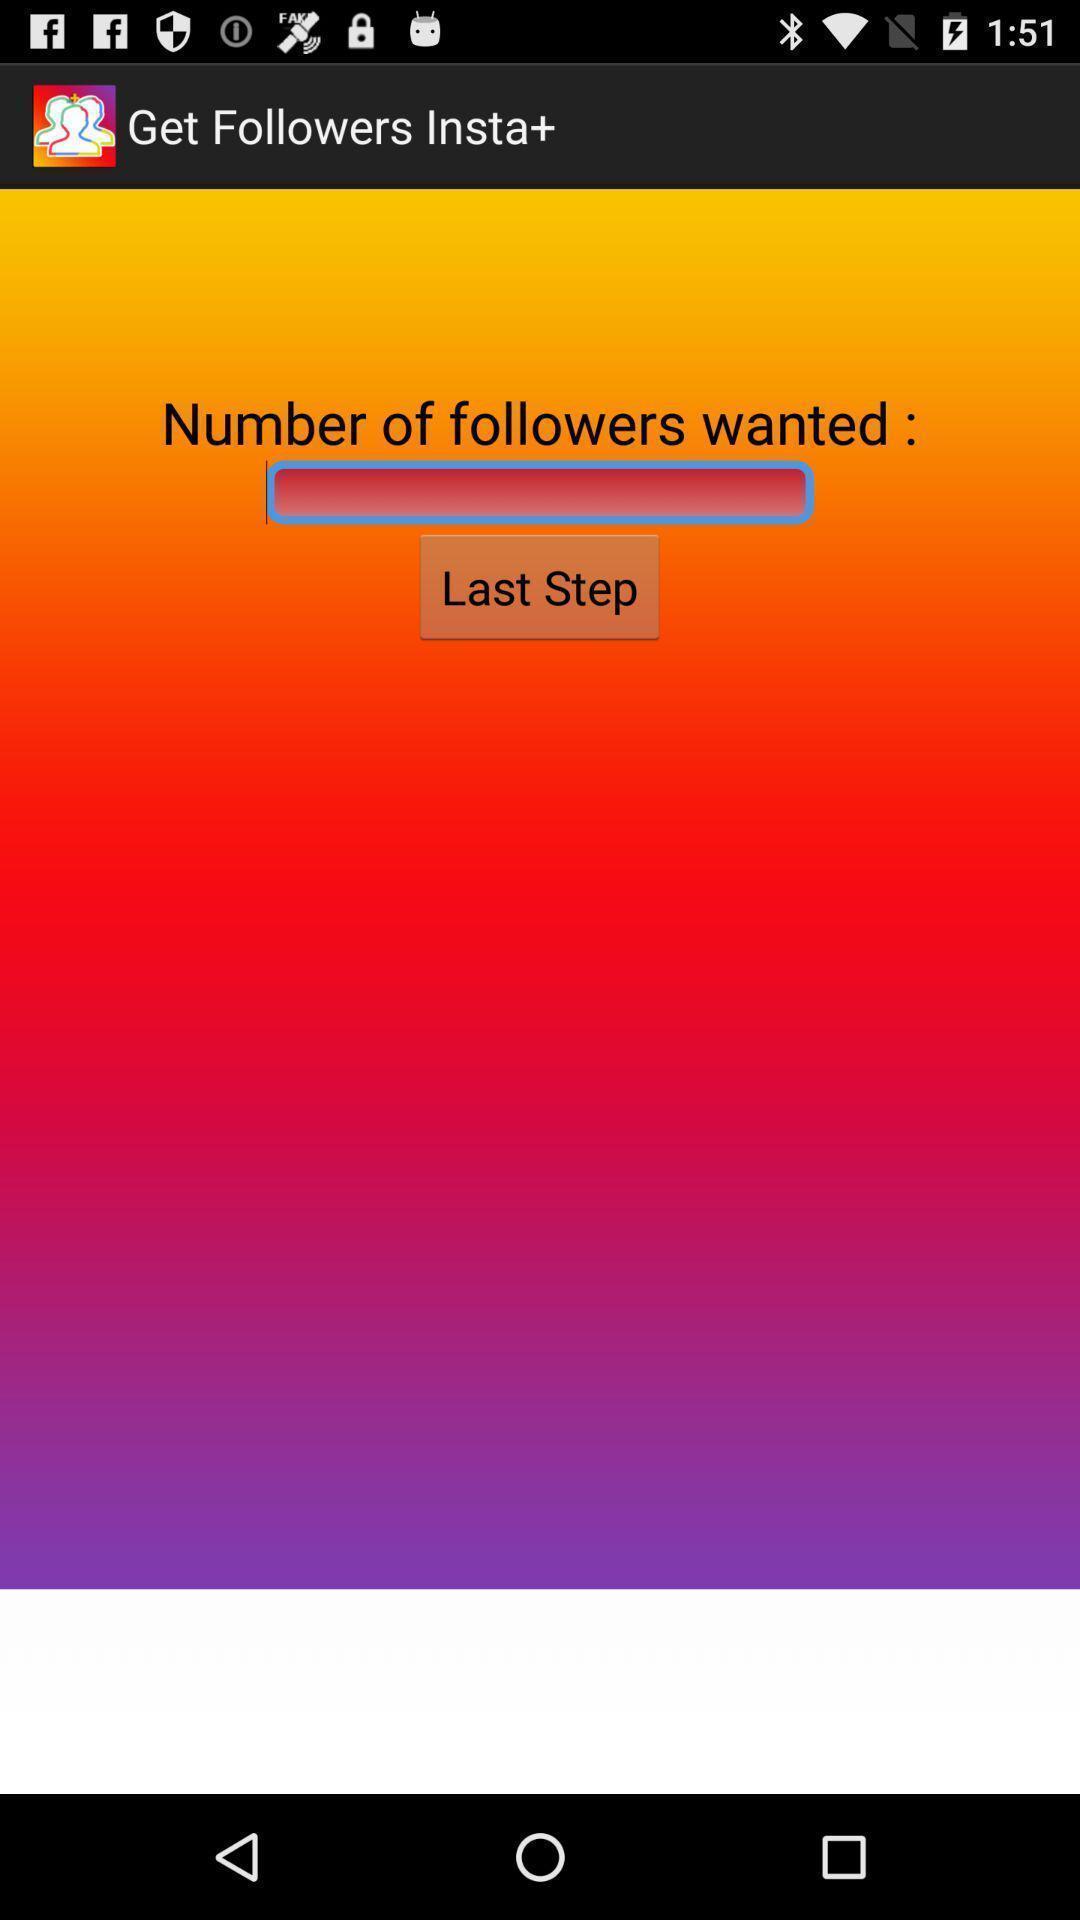Explain the elements present in this screenshot. Screen asking to get a number of followers. 